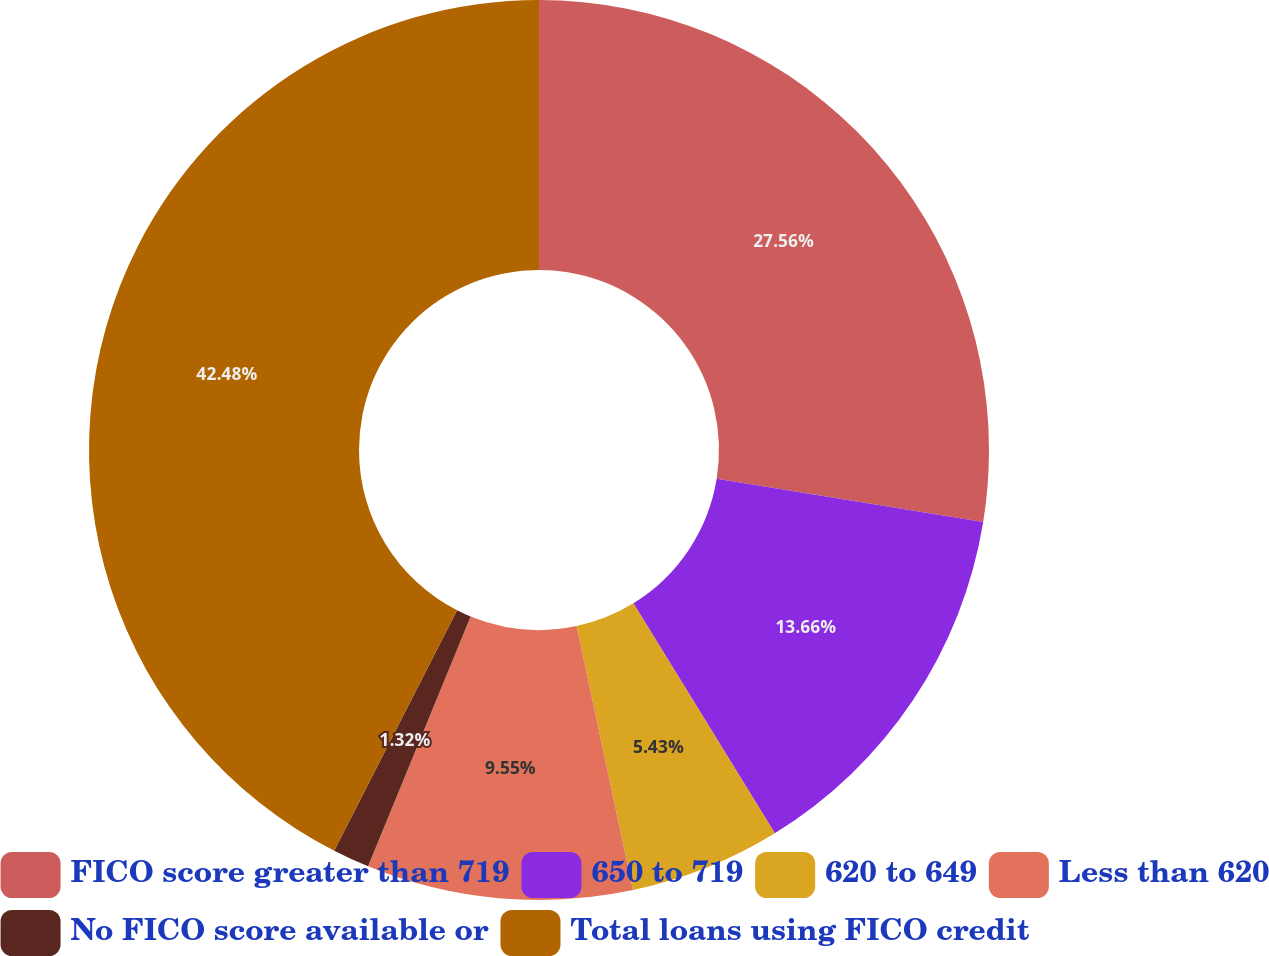Convert chart to OTSL. <chart><loc_0><loc_0><loc_500><loc_500><pie_chart><fcel>FICO score greater than 719<fcel>650 to 719<fcel>620 to 649<fcel>Less than 620<fcel>No FICO score available or<fcel>Total loans using FICO credit<nl><fcel>27.56%<fcel>13.66%<fcel>5.43%<fcel>9.55%<fcel>1.32%<fcel>42.48%<nl></chart> 